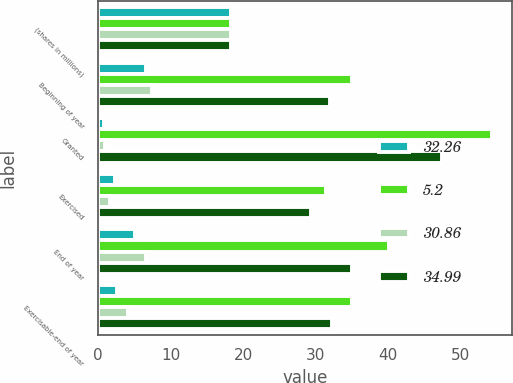<chart> <loc_0><loc_0><loc_500><loc_500><stacked_bar_chart><ecel><fcel>(shares in millions)<fcel>Beginning of year<fcel>Granted<fcel>Exercised<fcel>End of year<fcel>Exercisable-end of year<nl><fcel>32.26<fcel>18.375<fcel>6.6<fcel>0.9<fcel>2.4<fcel>5.1<fcel>2.7<nl><fcel>5.2<fcel>18.375<fcel>34.98<fcel>54.27<fcel>31.43<fcel>40.06<fcel>34.99<nl><fcel>30.86<fcel>18.375<fcel>7.4<fcel>1<fcel>1.7<fcel>6.6<fcel>4.2<nl><fcel>34.99<fcel>18.375<fcel>32.01<fcel>47.4<fcel>29.35<fcel>34.98<fcel>32.26<nl></chart> 